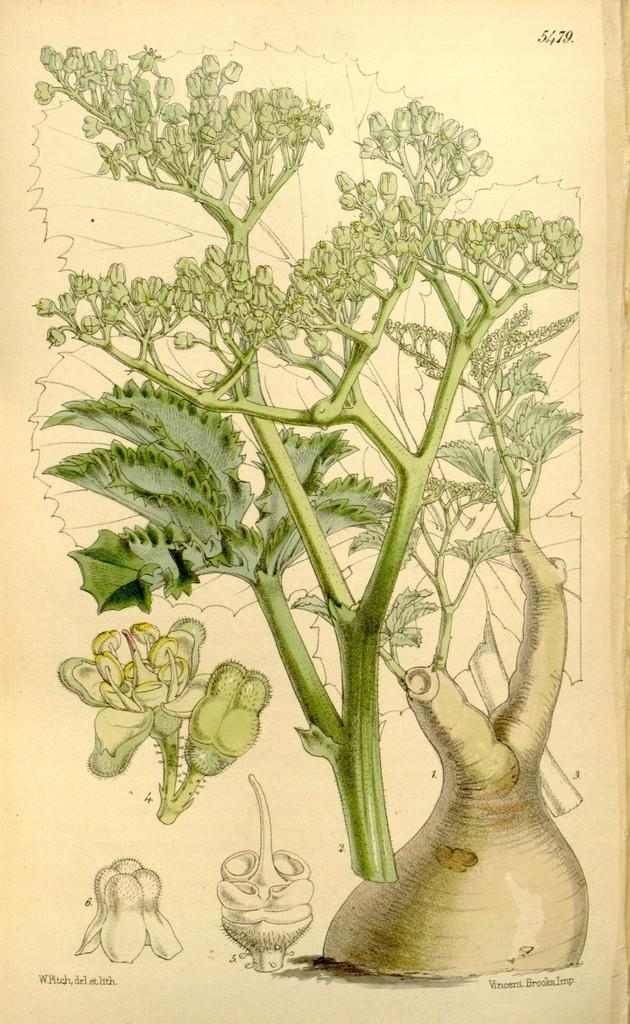What is the main subject of the image? There is a depiction of a plant in the image. What type of agreement is being signed by the plant in the image? There is no depiction of a person or any activity related to signing an agreement in the image; it features a plant. What is the tendency of the plant to grow in the image? The image does not show the plant growing or provide any information about its growth tendencies. 